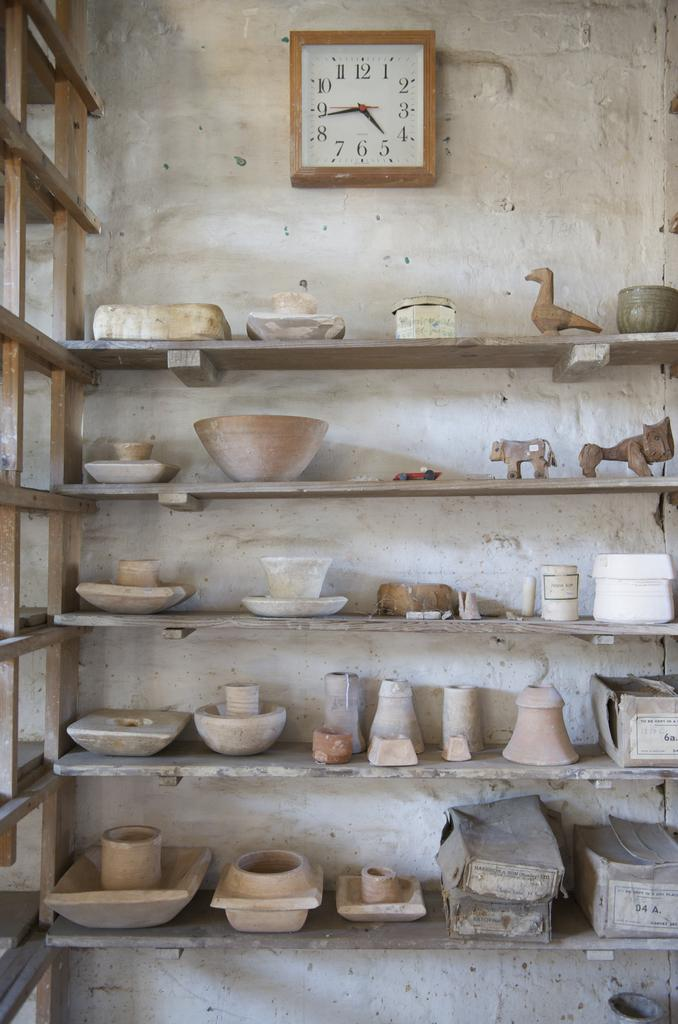Provide a one-sentence caption for the provided image. shelves of pottery with one labeled '04 A.'. 